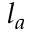Convert formula to latex. <formula><loc_0><loc_0><loc_500><loc_500>l _ { a }</formula> 